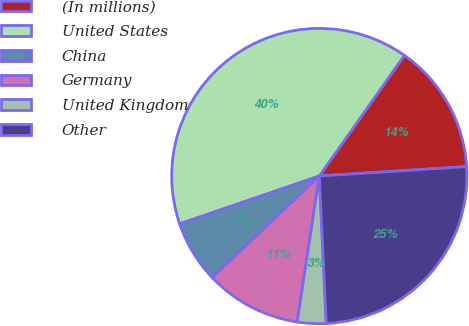Convert chart to OTSL. <chart><loc_0><loc_0><loc_500><loc_500><pie_chart><fcel>(In millions)<fcel>United States<fcel>China<fcel>Germany<fcel>United Kingdom<fcel>Other<nl><fcel>14.21%<fcel>40.03%<fcel>6.83%<fcel>10.52%<fcel>3.14%<fcel>25.28%<nl></chart> 